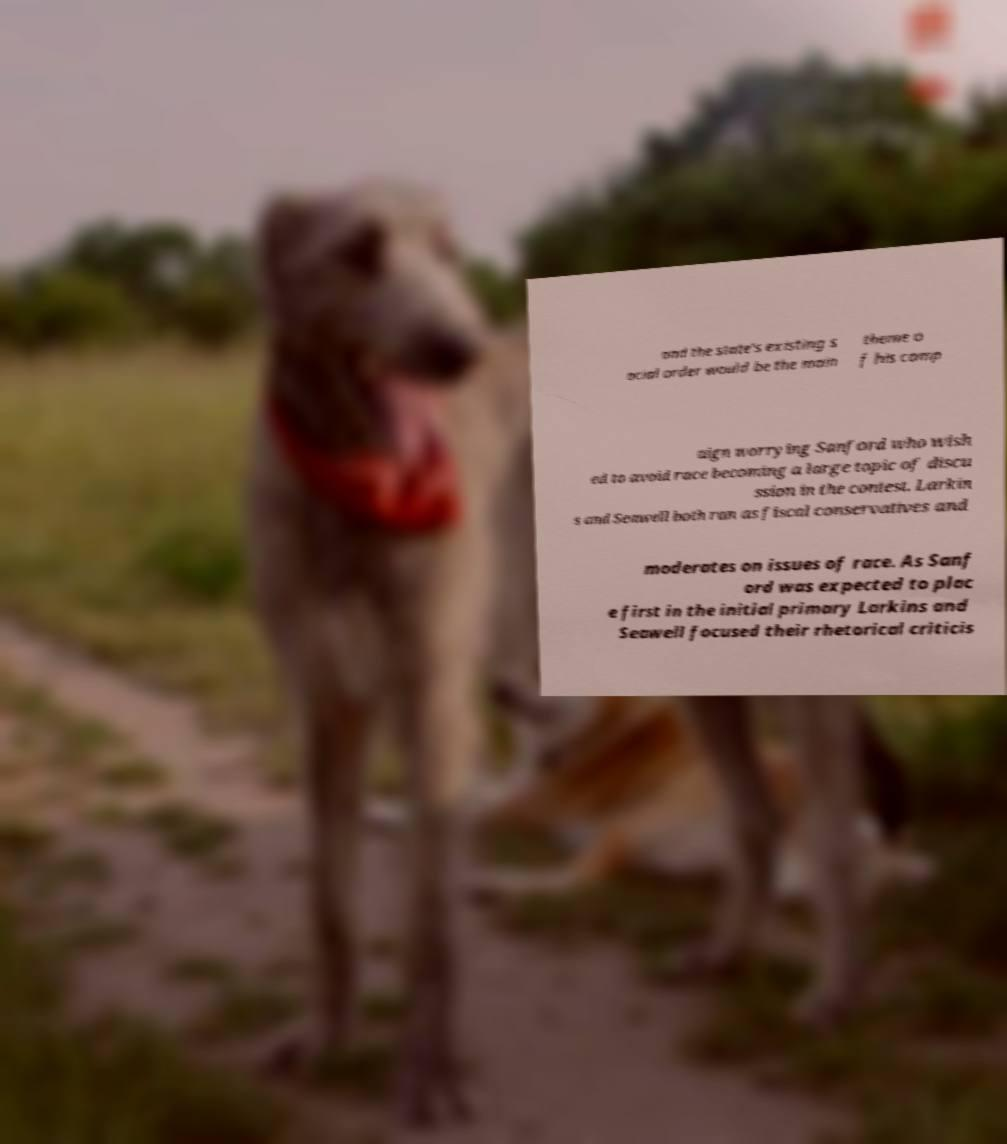Please identify and transcribe the text found in this image. and the state's existing s ocial order would be the main theme o f his camp aign worrying Sanford who wish ed to avoid race becoming a large topic of discu ssion in the contest. Larkin s and Seawell both ran as fiscal conservatives and moderates on issues of race. As Sanf ord was expected to plac e first in the initial primary Larkins and Seawell focused their rhetorical criticis 